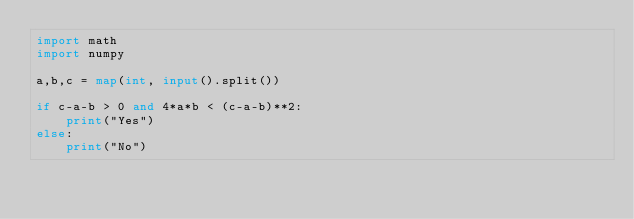Convert code to text. <code><loc_0><loc_0><loc_500><loc_500><_Python_>import math
import numpy
 
a,b,c = map(int, input().split())
 
if c-a-b > 0 and 4*a*b < (c-a-b)**2:
    print("Yes")
else:
    print("No")
</code> 